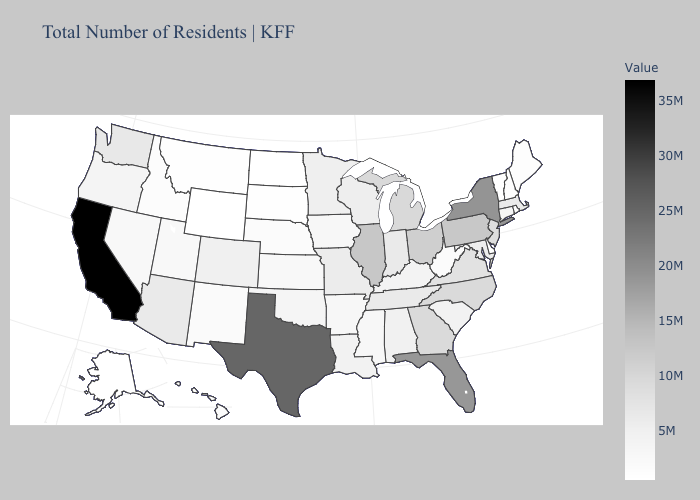Among the states that border Oklahoma , which have the lowest value?
Give a very brief answer. New Mexico. Does Alaska have the highest value in the USA?
Concise answer only. No. Does Wyoming have the lowest value in the USA?
Be succinct. Yes. Which states have the highest value in the USA?
Write a very short answer. California. Which states have the lowest value in the South?
Short answer required. Delaware. Does New Hampshire have the lowest value in the Northeast?
Answer briefly. No. Which states have the lowest value in the MidWest?
Write a very short answer. North Dakota. Does Wisconsin have the lowest value in the USA?
Keep it brief. No. Among the states that border Kentucky , which have the lowest value?
Short answer required. West Virginia. 